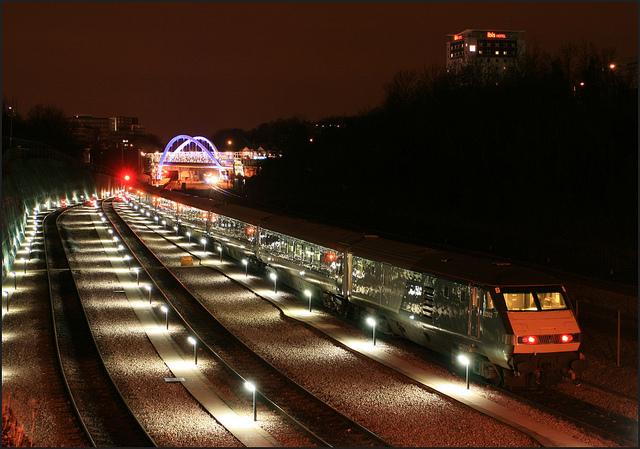Is it daytime?
Answer briefly. No. Is this a freight train?
Keep it brief. No. What is shown in the background?
Keep it brief. Bridge. 